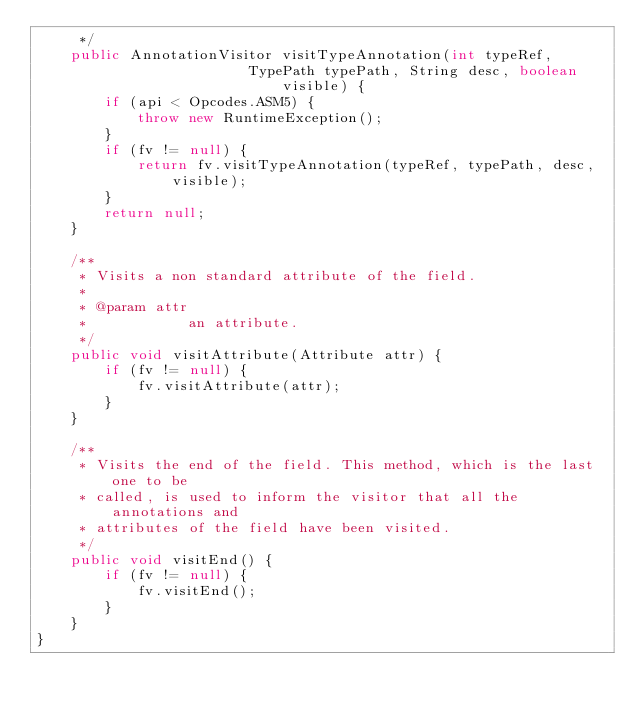<code> <loc_0><loc_0><loc_500><loc_500><_Java_>     */
    public AnnotationVisitor visitTypeAnnotation(int typeRef,
												 TypePath typePath, String desc, boolean visible) {
        if (api < Opcodes.ASM5) {
            throw new RuntimeException();
        }
        if (fv != null) {
            return fv.visitTypeAnnotation(typeRef, typePath, desc, visible);
        }
        return null;
    }

    /**
     * Visits a non standard attribute of the field.
     * 
     * @param attr
     *            an attribute.
     */
    public void visitAttribute(Attribute attr) {
        if (fv != null) {
            fv.visitAttribute(attr);
        }
    }

    /**
     * Visits the end of the field. This method, which is the last one to be
     * called, is used to inform the visitor that all the annotations and
     * attributes of the field have been visited.
     */
    public void visitEnd() {
        if (fv != null) {
            fv.visitEnd();
        }
    }
}
</code> 